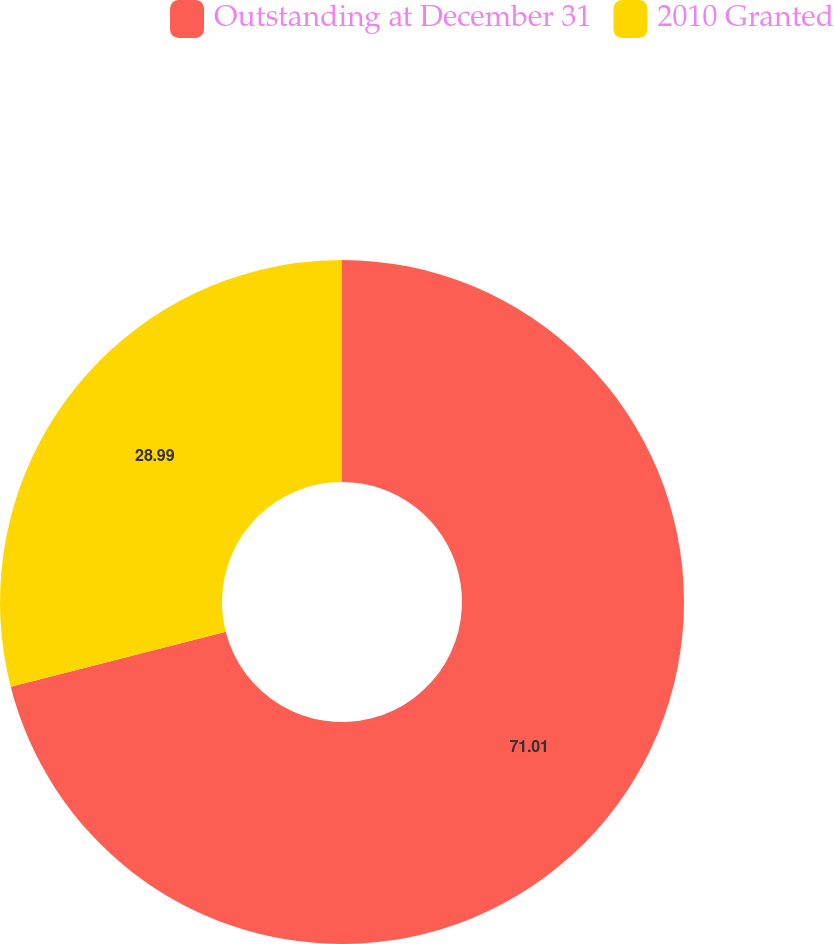<chart> <loc_0><loc_0><loc_500><loc_500><pie_chart><fcel>Outstanding at December 31<fcel>2010 Granted<nl><fcel>71.01%<fcel>28.99%<nl></chart> 